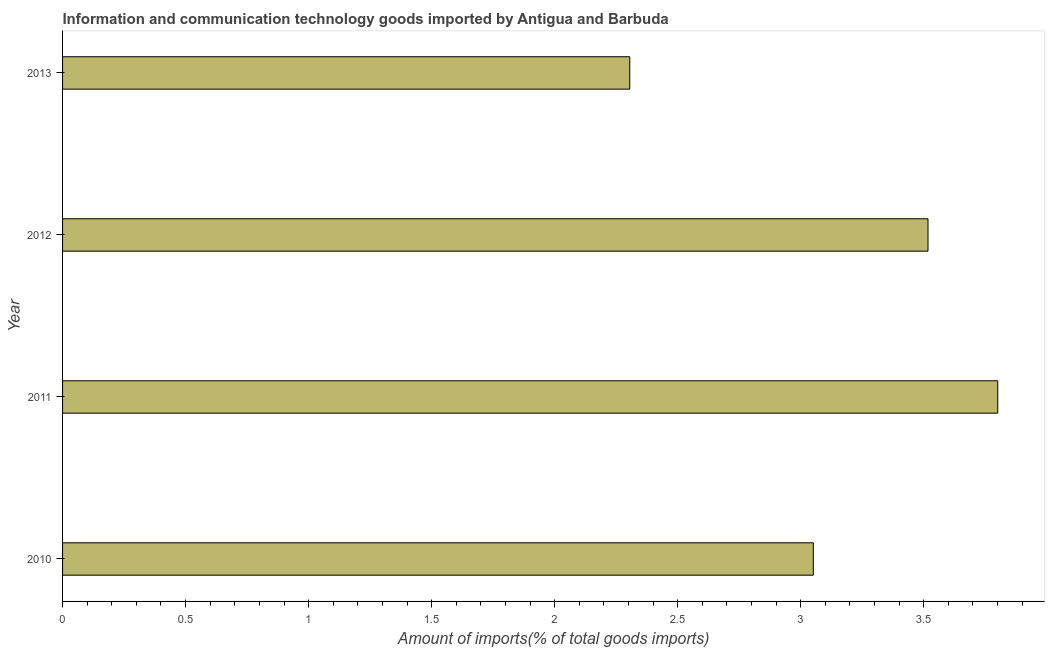Does the graph contain grids?
Give a very brief answer. No. What is the title of the graph?
Offer a terse response. Information and communication technology goods imported by Antigua and Barbuda. What is the label or title of the X-axis?
Your response must be concise. Amount of imports(% of total goods imports). What is the amount of ict goods imports in 2013?
Provide a succinct answer. 2.31. Across all years, what is the maximum amount of ict goods imports?
Your answer should be compact. 3.8. Across all years, what is the minimum amount of ict goods imports?
Your answer should be very brief. 2.31. In which year was the amount of ict goods imports maximum?
Your answer should be compact. 2011. What is the sum of the amount of ict goods imports?
Give a very brief answer. 12.67. What is the difference between the amount of ict goods imports in 2012 and 2013?
Your answer should be compact. 1.21. What is the average amount of ict goods imports per year?
Your answer should be very brief. 3.17. What is the median amount of ict goods imports?
Offer a very short reply. 3.28. What is the ratio of the amount of ict goods imports in 2011 to that in 2012?
Your answer should be very brief. 1.08. Is the difference between the amount of ict goods imports in 2010 and 2011 greater than the difference between any two years?
Ensure brevity in your answer.  No. What is the difference between the highest and the second highest amount of ict goods imports?
Make the answer very short. 0.28. Is the sum of the amount of ict goods imports in 2011 and 2013 greater than the maximum amount of ict goods imports across all years?
Offer a very short reply. Yes. In how many years, is the amount of ict goods imports greater than the average amount of ict goods imports taken over all years?
Provide a short and direct response. 2. How many bars are there?
Ensure brevity in your answer.  4. How many years are there in the graph?
Offer a very short reply. 4. Are the values on the major ticks of X-axis written in scientific E-notation?
Your answer should be compact. No. What is the Amount of imports(% of total goods imports) of 2010?
Your answer should be compact. 3.05. What is the Amount of imports(% of total goods imports) of 2011?
Offer a very short reply. 3.8. What is the Amount of imports(% of total goods imports) of 2012?
Your answer should be compact. 3.52. What is the Amount of imports(% of total goods imports) of 2013?
Provide a succinct answer. 2.31. What is the difference between the Amount of imports(% of total goods imports) in 2010 and 2011?
Your answer should be compact. -0.75. What is the difference between the Amount of imports(% of total goods imports) in 2010 and 2012?
Make the answer very short. -0.47. What is the difference between the Amount of imports(% of total goods imports) in 2010 and 2013?
Provide a succinct answer. 0.75. What is the difference between the Amount of imports(% of total goods imports) in 2011 and 2012?
Give a very brief answer. 0.28. What is the difference between the Amount of imports(% of total goods imports) in 2011 and 2013?
Your response must be concise. 1.5. What is the difference between the Amount of imports(% of total goods imports) in 2012 and 2013?
Offer a terse response. 1.21. What is the ratio of the Amount of imports(% of total goods imports) in 2010 to that in 2011?
Provide a short and direct response. 0.8. What is the ratio of the Amount of imports(% of total goods imports) in 2010 to that in 2012?
Give a very brief answer. 0.87. What is the ratio of the Amount of imports(% of total goods imports) in 2010 to that in 2013?
Keep it short and to the point. 1.32. What is the ratio of the Amount of imports(% of total goods imports) in 2011 to that in 2012?
Your answer should be compact. 1.08. What is the ratio of the Amount of imports(% of total goods imports) in 2011 to that in 2013?
Your response must be concise. 1.65. What is the ratio of the Amount of imports(% of total goods imports) in 2012 to that in 2013?
Make the answer very short. 1.53. 